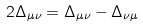<formula> <loc_0><loc_0><loc_500><loc_500>2 \Delta _ { \mu \nu } = \Delta _ { \mu \nu } - \Delta _ { \nu \mu }</formula> 